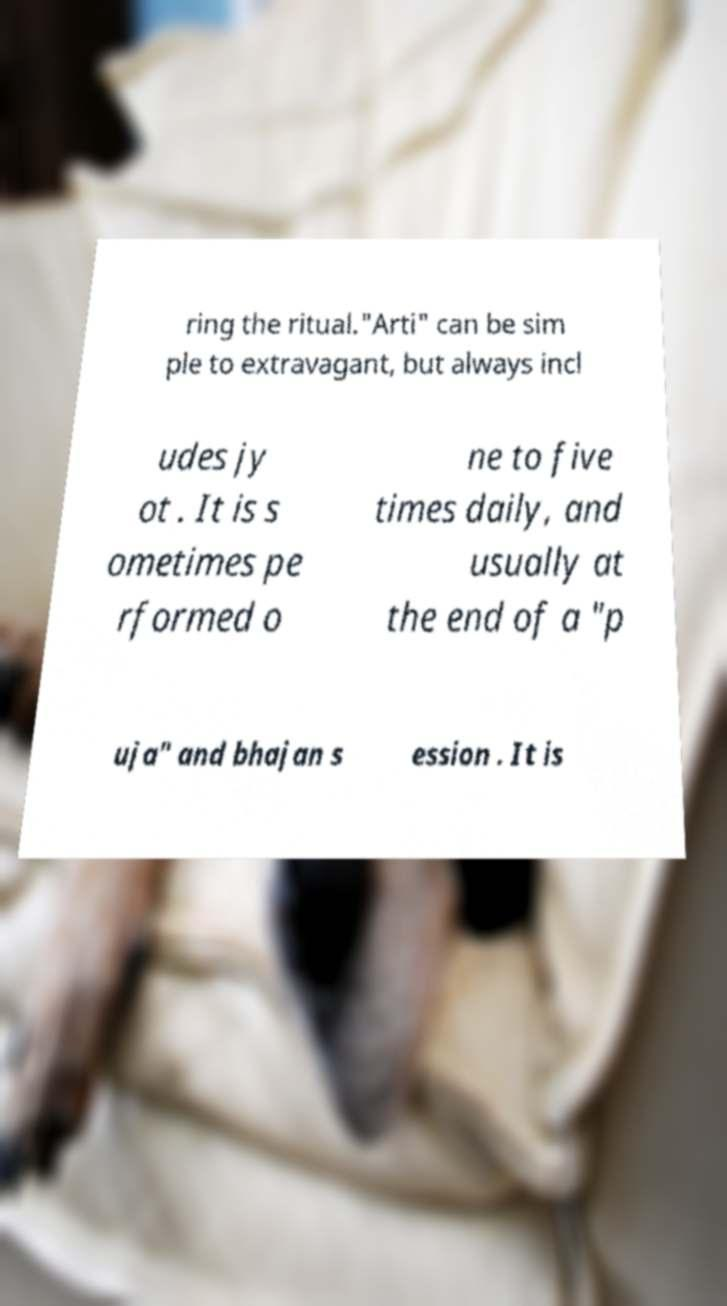What messages or text are displayed in this image? I need them in a readable, typed format. ring the ritual."Arti" can be sim ple to extravagant, but always incl udes jy ot . It is s ometimes pe rformed o ne to five times daily, and usually at the end of a "p uja" and bhajan s ession . It is 